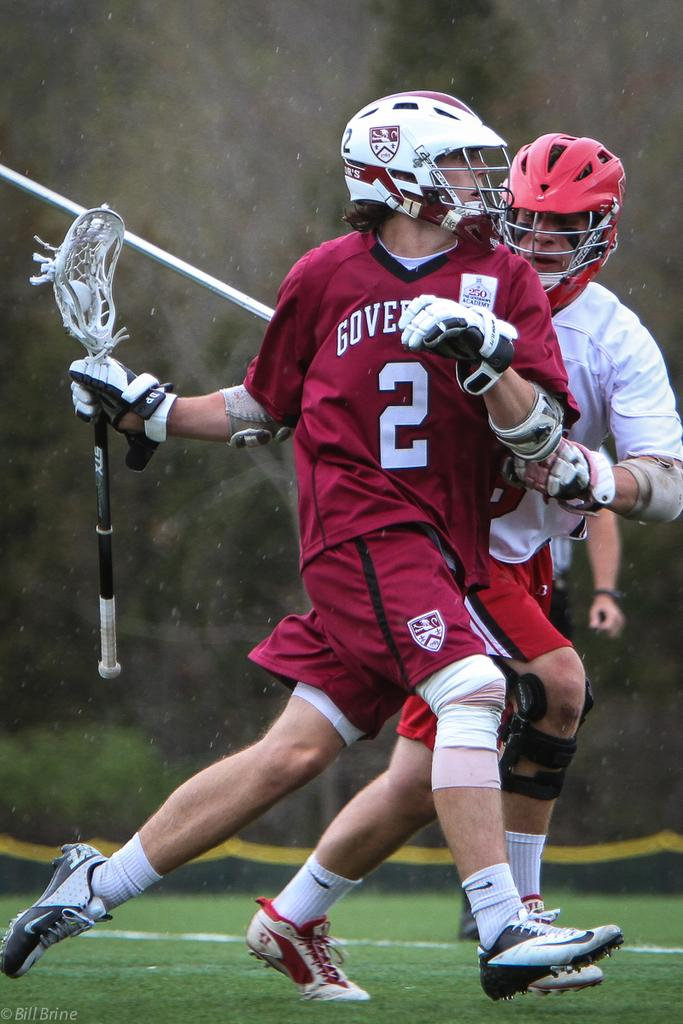<image>
Write a terse but informative summary of the picture. A lacrosse player wears a uniform with the number 2 on the front. 